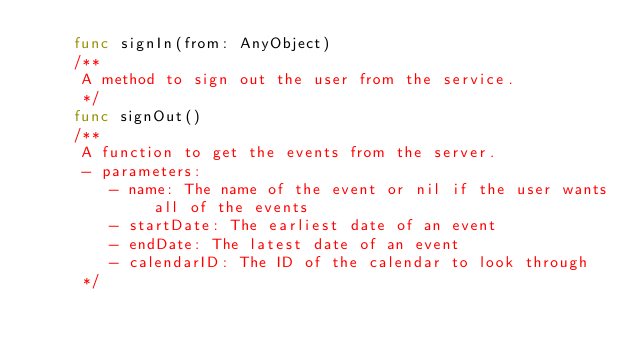Convert code to text. <code><loc_0><loc_0><loc_500><loc_500><_Swift_>    func signIn(from: AnyObject)
    /**
     A method to sign out the user from the service.
     */
    func signOut()
    /**
     A function to get the events from the server.
     - parameters:
        - name: The name of the event or nil if the user wants all of the events
        - startDate: The earliest date of an event
        - endDate: The latest date of an event
        - calendarID: The ID of the calendar to look through
     */</code> 